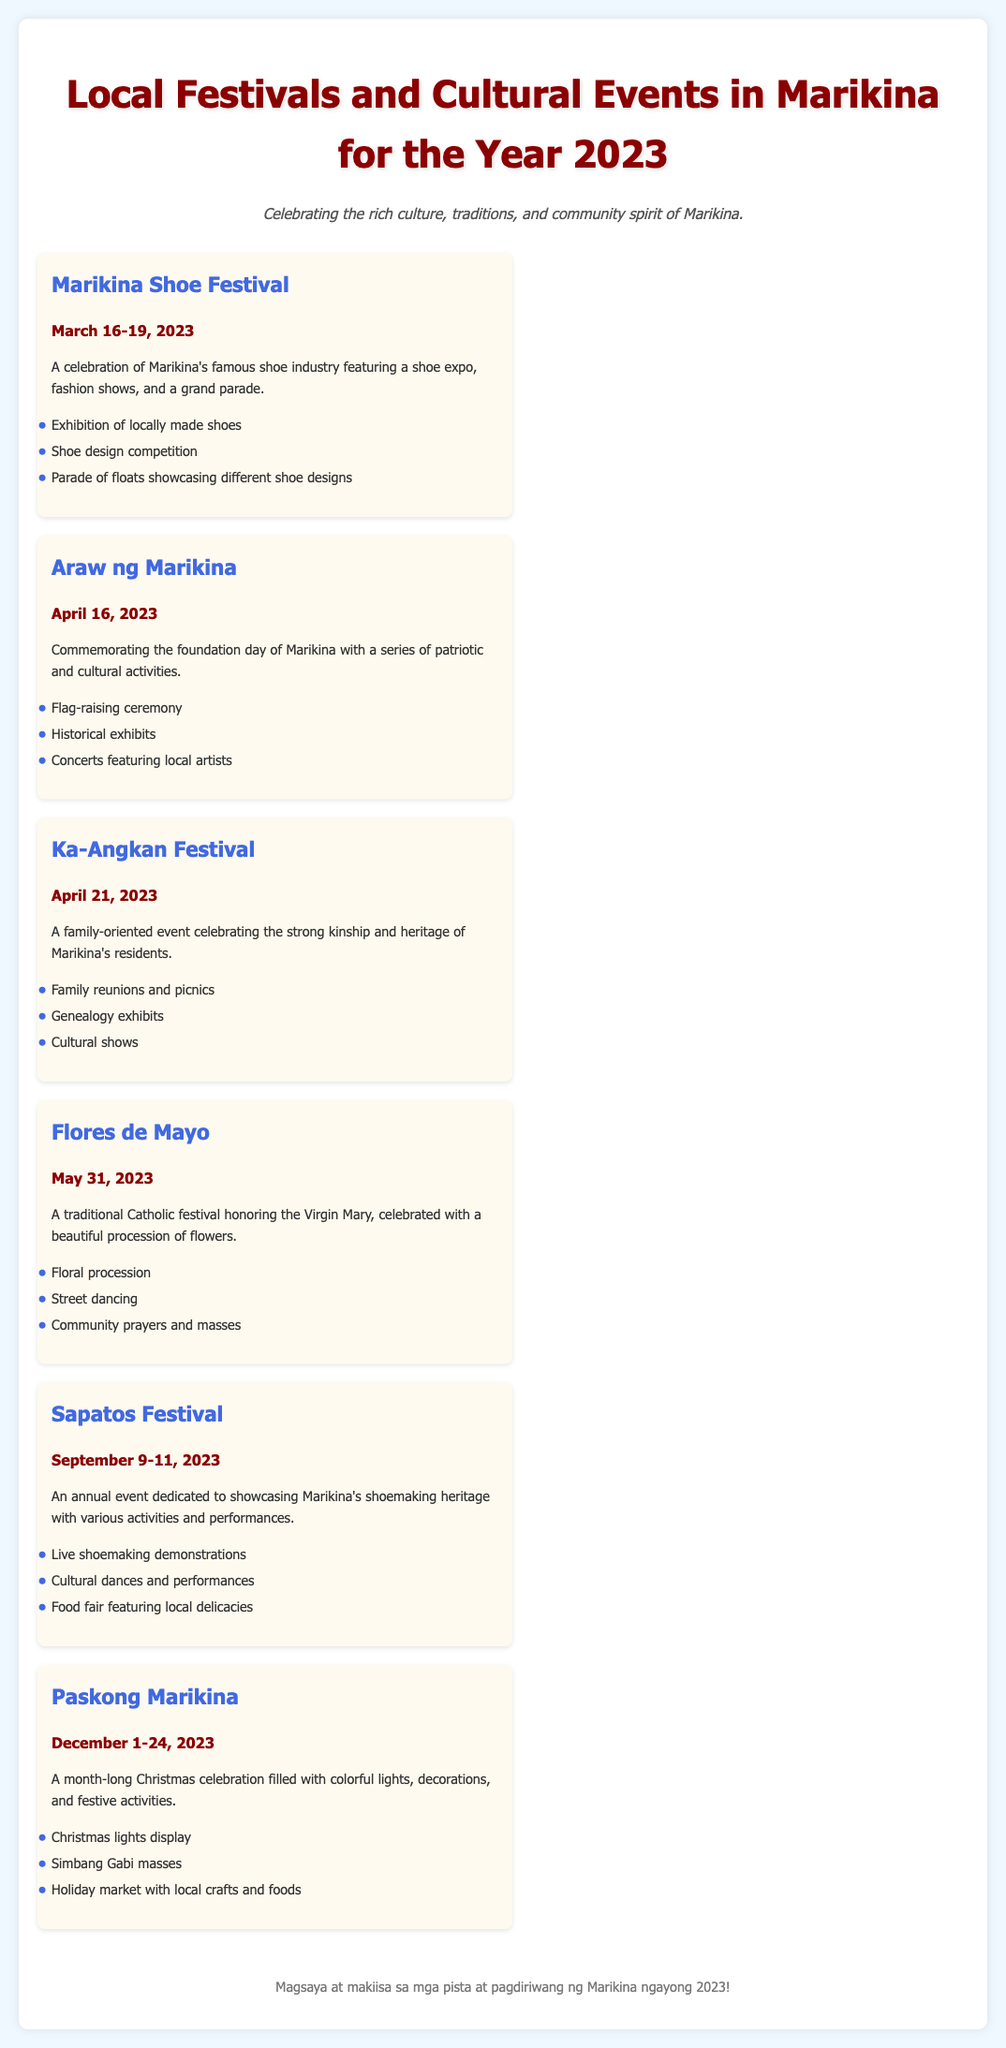What event is celebrated from March 16-19, 2023? The event celebrated during this date is the Marikina Shoe Festival, highlighting the shoe industry of Marikina.
Answer: Marikina Shoe Festival What date is Araw ng Marikina observed? Araw ng Marikina commemorates the foundation day of Marikina and is observed on April 16, 2023.
Answer: April 16, 2023 What are the key activities during the Ka-Angkan Festival? The key activities during the Ka-Angkan Festival include family reunions, genealogy exhibits, and cultural shows.
Answer: Family reunions, genealogy exhibits, cultural shows When does the Paskong Marikina celebration start? Paskong Marikina starts on December 1 and lasts until December 24, 2023.
Answer: December 1 What festival features a floral procession? The festival featuring a floral procession is Flores de Mayo, celebrated on May 31, 2023.
Answer: Flores de Mayo How many days does the Sapatos Festival last? The Sapatos Festival lasts for three days, from September 9 to September 11, 2023.
Answer: Three days What type of event is the Paskong Marikina? Paskong Marikina is a month-long Christmas celebration filled with festive activities and decorations.
Answer: Month-long Christmas celebration What is highlighted during the Marikina Shoe Festival? The Marikina Shoe Festival highlights the famous shoe industry of Marikina through various activities.
Answer: Shoe industry 